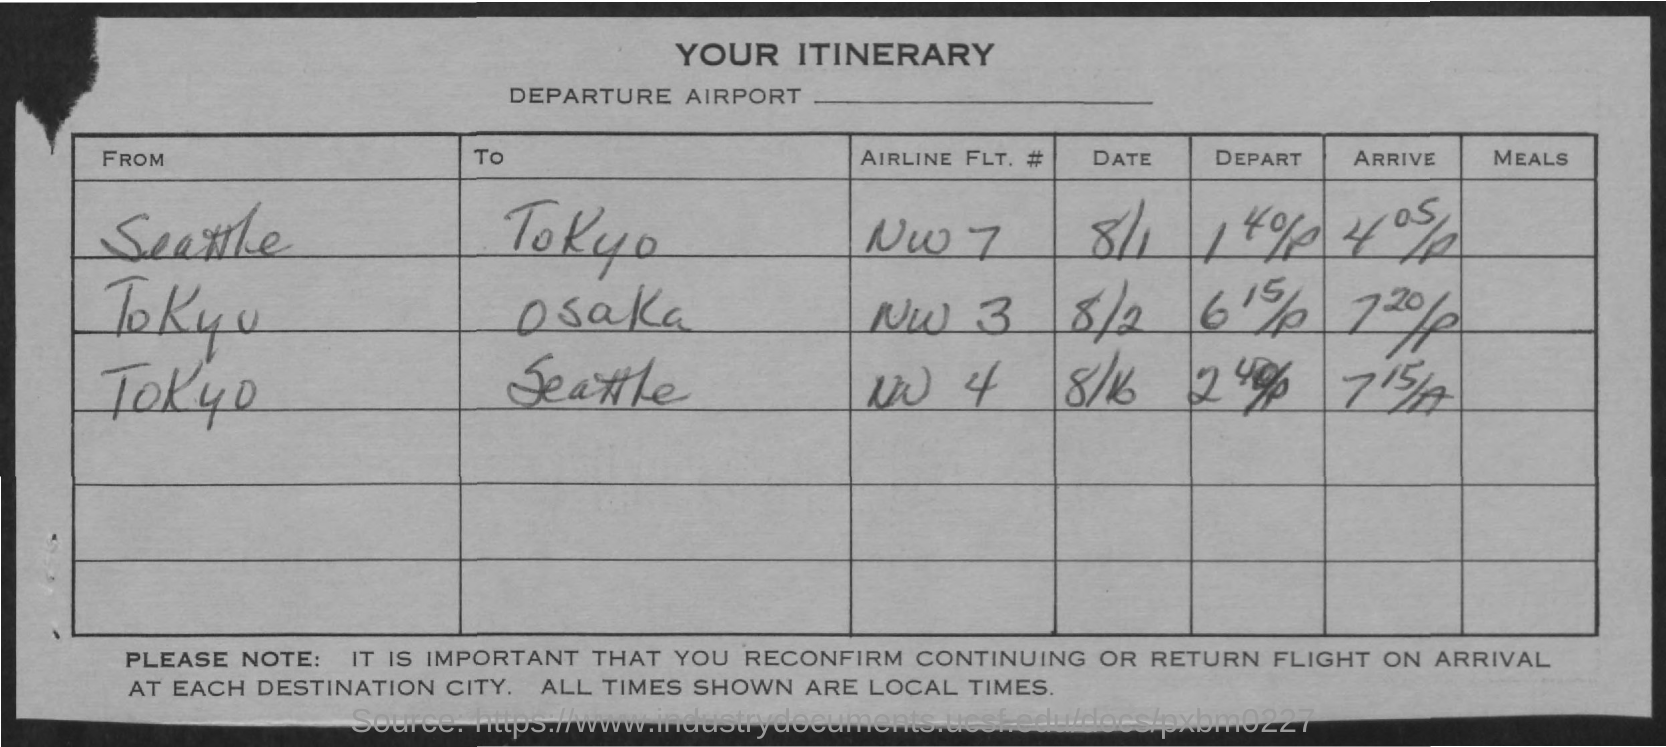List a handful of essential elements in this visual. Northwest Airlines flight number 7 is traveling from Seattle, Washington to Tokyo, Japan. The airline flight number from Tokyo to Osaka is NW 3. The airline flight number from Tokyo to Seattle is Northwest Flight 4. On August 2nd, Airline Flight #NW 3 departed from Tokyo and arrived in Osaka. On August 16th, Airline Flight Number NW 4 departed from Tokyo and arrived in Seattle. 